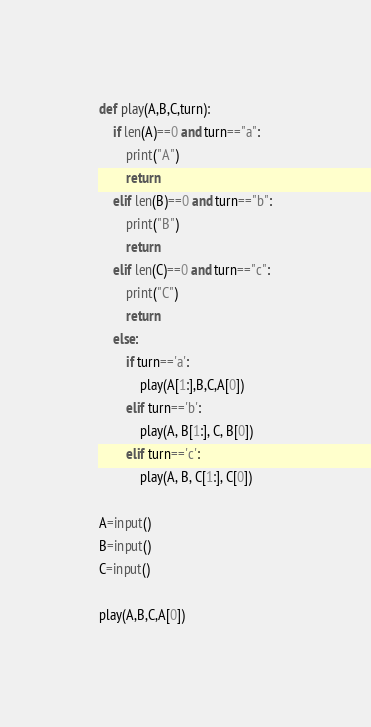<code> <loc_0><loc_0><loc_500><loc_500><_Python_>
def play(A,B,C,turn):
    if len(A)==0 and turn=="a":
        print("A")
        return
    elif len(B)==0 and turn=="b":
        print("B")
        return
    elif len(C)==0 and turn=="c":
        print("C")
        return
    else:
        if turn=='a':
            play(A[1:],B,C,A[0])
        elif turn=='b':
            play(A, B[1:], C, B[0])
        elif turn=='c':
            play(A, B, C[1:], C[0])

A=input()
B=input()
C=input()

play(A,B,C,A[0])</code> 